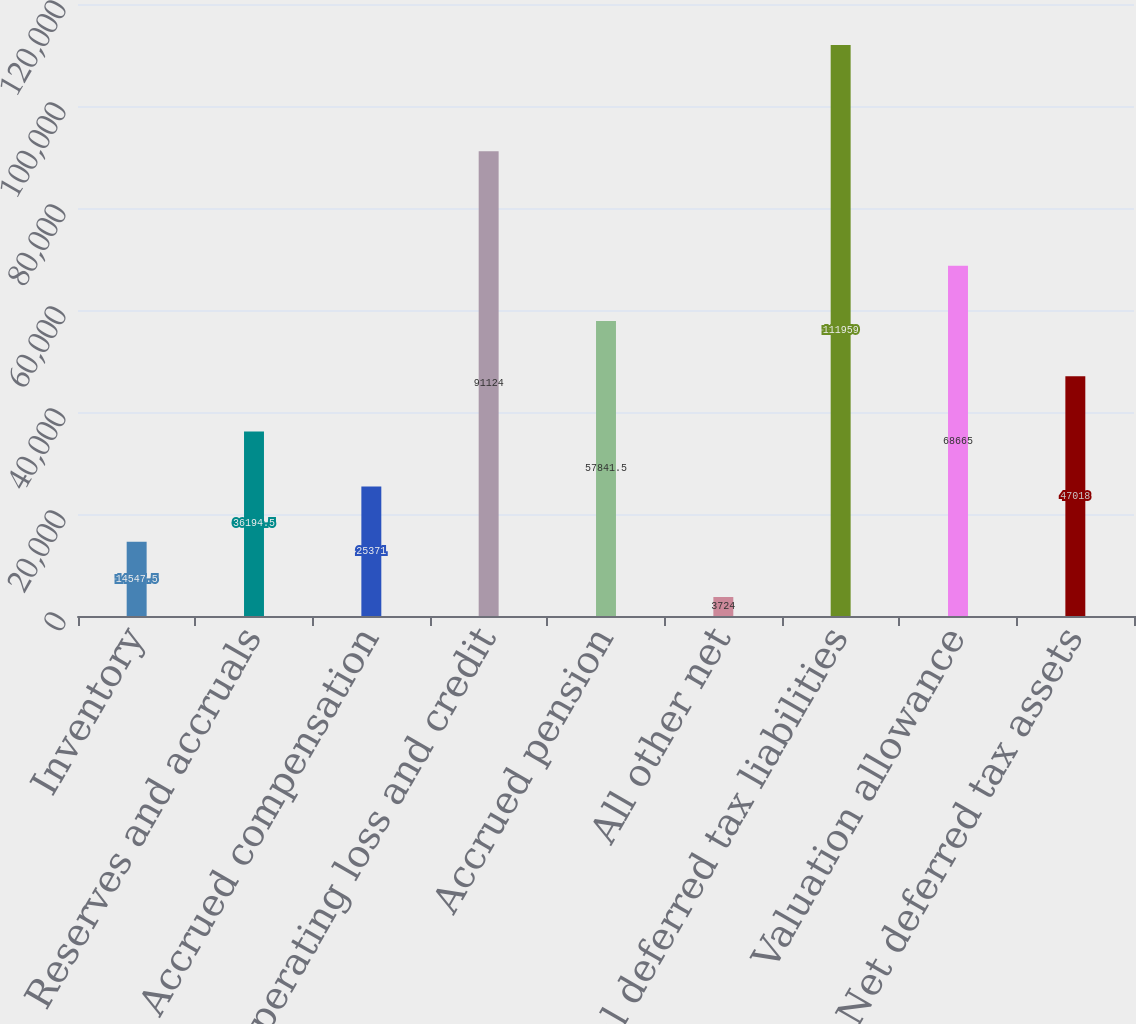<chart> <loc_0><loc_0><loc_500><loc_500><bar_chart><fcel>Inventory<fcel>Reserves and accruals<fcel>Accrued compensation<fcel>Net operating loss and credit<fcel>Accrued pension<fcel>All other net<fcel>Total deferred tax liabilities<fcel>Valuation allowance<fcel>Net deferred tax assets<nl><fcel>14547.5<fcel>36194.5<fcel>25371<fcel>91124<fcel>57841.5<fcel>3724<fcel>111959<fcel>68665<fcel>47018<nl></chart> 